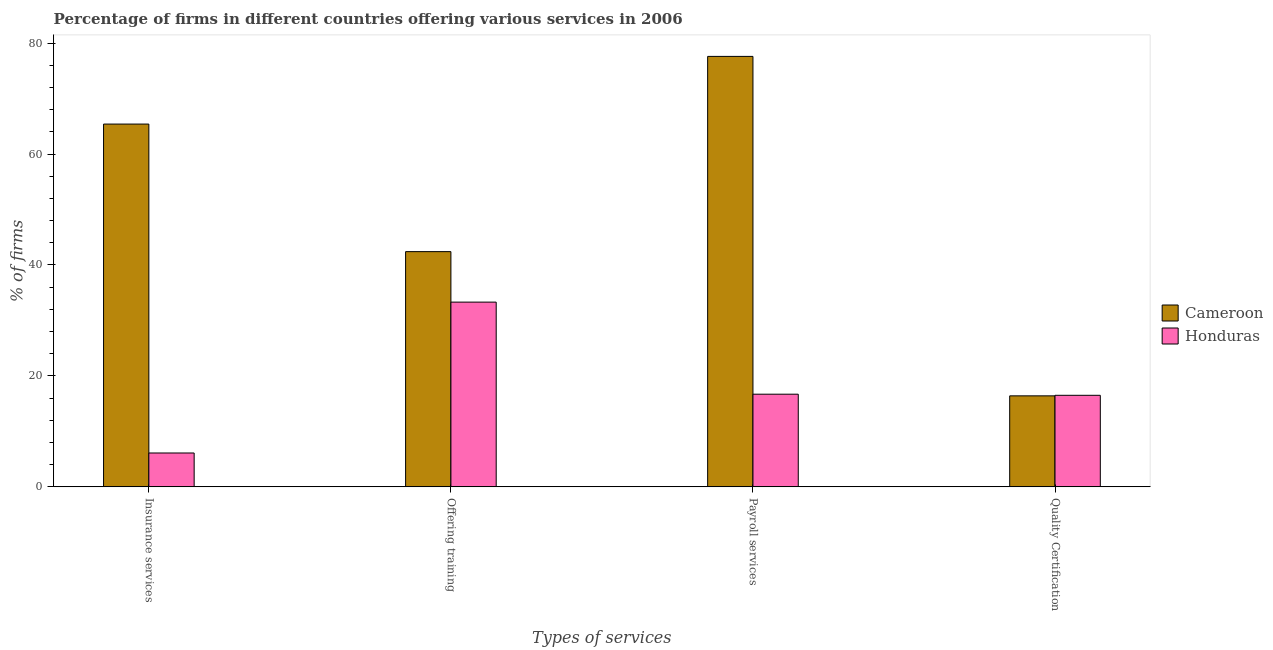How many groups of bars are there?
Offer a very short reply. 4. Are the number of bars per tick equal to the number of legend labels?
Offer a terse response. Yes. How many bars are there on the 2nd tick from the left?
Your response must be concise. 2. How many bars are there on the 4th tick from the right?
Provide a short and direct response. 2. What is the label of the 4th group of bars from the left?
Provide a succinct answer. Quality Certification. What is the percentage of firms offering quality certification in Cameroon?
Provide a succinct answer. 16.4. Across all countries, what is the maximum percentage of firms offering insurance services?
Give a very brief answer. 65.4. In which country was the percentage of firms offering quality certification maximum?
Your answer should be very brief. Honduras. In which country was the percentage of firms offering payroll services minimum?
Offer a very short reply. Honduras. What is the total percentage of firms offering quality certification in the graph?
Your answer should be compact. 32.9. What is the difference between the percentage of firms offering training in Honduras and that in Cameroon?
Keep it short and to the point. -9.1. What is the difference between the percentage of firms offering insurance services in Honduras and the percentage of firms offering quality certification in Cameroon?
Make the answer very short. -10.3. What is the average percentage of firms offering training per country?
Ensure brevity in your answer.  37.85. What is the difference between the percentage of firms offering quality certification and percentage of firms offering insurance services in Cameroon?
Provide a short and direct response. -49. What is the ratio of the percentage of firms offering quality certification in Honduras to that in Cameroon?
Your response must be concise. 1.01. Is the difference between the percentage of firms offering quality certification in Honduras and Cameroon greater than the difference between the percentage of firms offering payroll services in Honduras and Cameroon?
Your answer should be compact. Yes. What is the difference between the highest and the second highest percentage of firms offering payroll services?
Keep it short and to the point. 60.9. What is the difference between the highest and the lowest percentage of firms offering quality certification?
Your answer should be compact. 0.1. In how many countries, is the percentage of firms offering quality certification greater than the average percentage of firms offering quality certification taken over all countries?
Your response must be concise. 1. Is the sum of the percentage of firms offering insurance services in Honduras and Cameroon greater than the maximum percentage of firms offering training across all countries?
Make the answer very short. Yes. What does the 1st bar from the left in Quality Certification represents?
Offer a terse response. Cameroon. What does the 2nd bar from the right in Payroll services represents?
Offer a terse response. Cameroon. Is it the case that in every country, the sum of the percentage of firms offering insurance services and percentage of firms offering training is greater than the percentage of firms offering payroll services?
Provide a short and direct response. Yes. How many bars are there?
Make the answer very short. 8. How many countries are there in the graph?
Keep it short and to the point. 2. What is the difference between two consecutive major ticks on the Y-axis?
Your response must be concise. 20. Does the graph contain any zero values?
Offer a terse response. No. Does the graph contain grids?
Keep it short and to the point. No. Where does the legend appear in the graph?
Provide a short and direct response. Center right. How many legend labels are there?
Offer a very short reply. 2. What is the title of the graph?
Provide a short and direct response. Percentage of firms in different countries offering various services in 2006. Does "Myanmar" appear as one of the legend labels in the graph?
Offer a very short reply. No. What is the label or title of the X-axis?
Your response must be concise. Types of services. What is the label or title of the Y-axis?
Provide a short and direct response. % of firms. What is the % of firms in Cameroon in Insurance services?
Provide a succinct answer. 65.4. What is the % of firms in Cameroon in Offering training?
Ensure brevity in your answer.  42.4. What is the % of firms in Honduras in Offering training?
Give a very brief answer. 33.3. What is the % of firms of Cameroon in Payroll services?
Your answer should be very brief. 77.6. What is the % of firms of Cameroon in Quality Certification?
Your response must be concise. 16.4. Across all Types of services, what is the maximum % of firms of Cameroon?
Provide a succinct answer. 77.6. Across all Types of services, what is the maximum % of firms of Honduras?
Keep it short and to the point. 33.3. Across all Types of services, what is the minimum % of firms in Cameroon?
Make the answer very short. 16.4. Across all Types of services, what is the minimum % of firms of Honduras?
Offer a very short reply. 6.1. What is the total % of firms in Cameroon in the graph?
Make the answer very short. 201.8. What is the total % of firms in Honduras in the graph?
Provide a succinct answer. 72.6. What is the difference between the % of firms in Cameroon in Insurance services and that in Offering training?
Provide a succinct answer. 23. What is the difference between the % of firms of Honduras in Insurance services and that in Offering training?
Offer a very short reply. -27.2. What is the difference between the % of firms of Honduras in Insurance services and that in Payroll services?
Your answer should be very brief. -10.6. What is the difference between the % of firms of Cameroon in Insurance services and that in Quality Certification?
Provide a succinct answer. 49. What is the difference between the % of firms in Honduras in Insurance services and that in Quality Certification?
Your response must be concise. -10.4. What is the difference between the % of firms of Cameroon in Offering training and that in Payroll services?
Ensure brevity in your answer.  -35.2. What is the difference between the % of firms in Honduras in Offering training and that in Payroll services?
Your response must be concise. 16.6. What is the difference between the % of firms of Cameroon in Offering training and that in Quality Certification?
Give a very brief answer. 26. What is the difference between the % of firms in Cameroon in Payroll services and that in Quality Certification?
Your response must be concise. 61.2. What is the difference between the % of firms of Honduras in Payroll services and that in Quality Certification?
Keep it short and to the point. 0.2. What is the difference between the % of firms of Cameroon in Insurance services and the % of firms of Honduras in Offering training?
Offer a terse response. 32.1. What is the difference between the % of firms of Cameroon in Insurance services and the % of firms of Honduras in Payroll services?
Make the answer very short. 48.7. What is the difference between the % of firms of Cameroon in Insurance services and the % of firms of Honduras in Quality Certification?
Keep it short and to the point. 48.9. What is the difference between the % of firms of Cameroon in Offering training and the % of firms of Honduras in Payroll services?
Make the answer very short. 25.7. What is the difference between the % of firms of Cameroon in Offering training and the % of firms of Honduras in Quality Certification?
Make the answer very short. 25.9. What is the difference between the % of firms of Cameroon in Payroll services and the % of firms of Honduras in Quality Certification?
Offer a terse response. 61.1. What is the average % of firms in Cameroon per Types of services?
Your answer should be compact. 50.45. What is the average % of firms in Honduras per Types of services?
Provide a short and direct response. 18.15. What is the difference between the % of firms in Cameroon and % of firms in Honduras in Insurance services?
Provide a short and direct response. 59.3. What is the difference between the % of firms in Cameroon and % of firms in Honduras in Offering training?
Offer a terse response. 9.1. What is the difference between the % of firms of Cameroon and % of firms of Honduras in Payroll services?
Ensure brevity in your answer.  60.9. What is the ratio of the % of firms in Cameroon in Insurance services to that in Offering training?
Offer a very short reply. 1.54. What is the ratio of the % of firms of Honduras in Insurance services to that in Offering training?
Make the answer very short. 0.18. What is the ratio of the % of firms in Cameroon in Insurance services to that in Payroll services?
Give a very brief answer. 0.84. What is the ratio of the % of firms of Honduras in Insurance services to that in Payroll services?
Provide a succinct answer. 0.37. What is the ratio of the % of firms in Cameroon in Insurance services to that in Quality Certification?
Your answer should be compact. 3.99. What is the ratio of the % of firms in Honduras in Insurance services to that in Quality Certification?
Ensure brevity in your answer.  0.37. What is the ratio of the % of firms of Cameroon in Offering training to that in Payroll services?
Your response must be concise. 0.55. What is the ratio of the % of firms in Honduras in Offering training to that in Payroll services?
Offer a terse response. 1.99. What is the ratio of the % of firms in Cameroon in Offering training to that in Quality Certification?
Your answer should be compact. 2.59. What is the ratio of the % of firms of Honduras in Offering training to that in Quality Certification?
Your answer should be very brief. 2.02. What is the ratio of the % of firms in Cameroon in Payroll services to that in Quality Certification?
Offer a terse response. 4.73. What is the ratio of the % of firms in Honduras in Payroll services to that in Quality Certification?
Provide a short and direct response. 1.01. What is the difference between the highest and the lowest % of firms of Cameroon?
Your answer should be very brief. 61.2. What is the difference between the highest and the lowest % of firms of Honduras?
Provide a succinct answer. 27.2. 